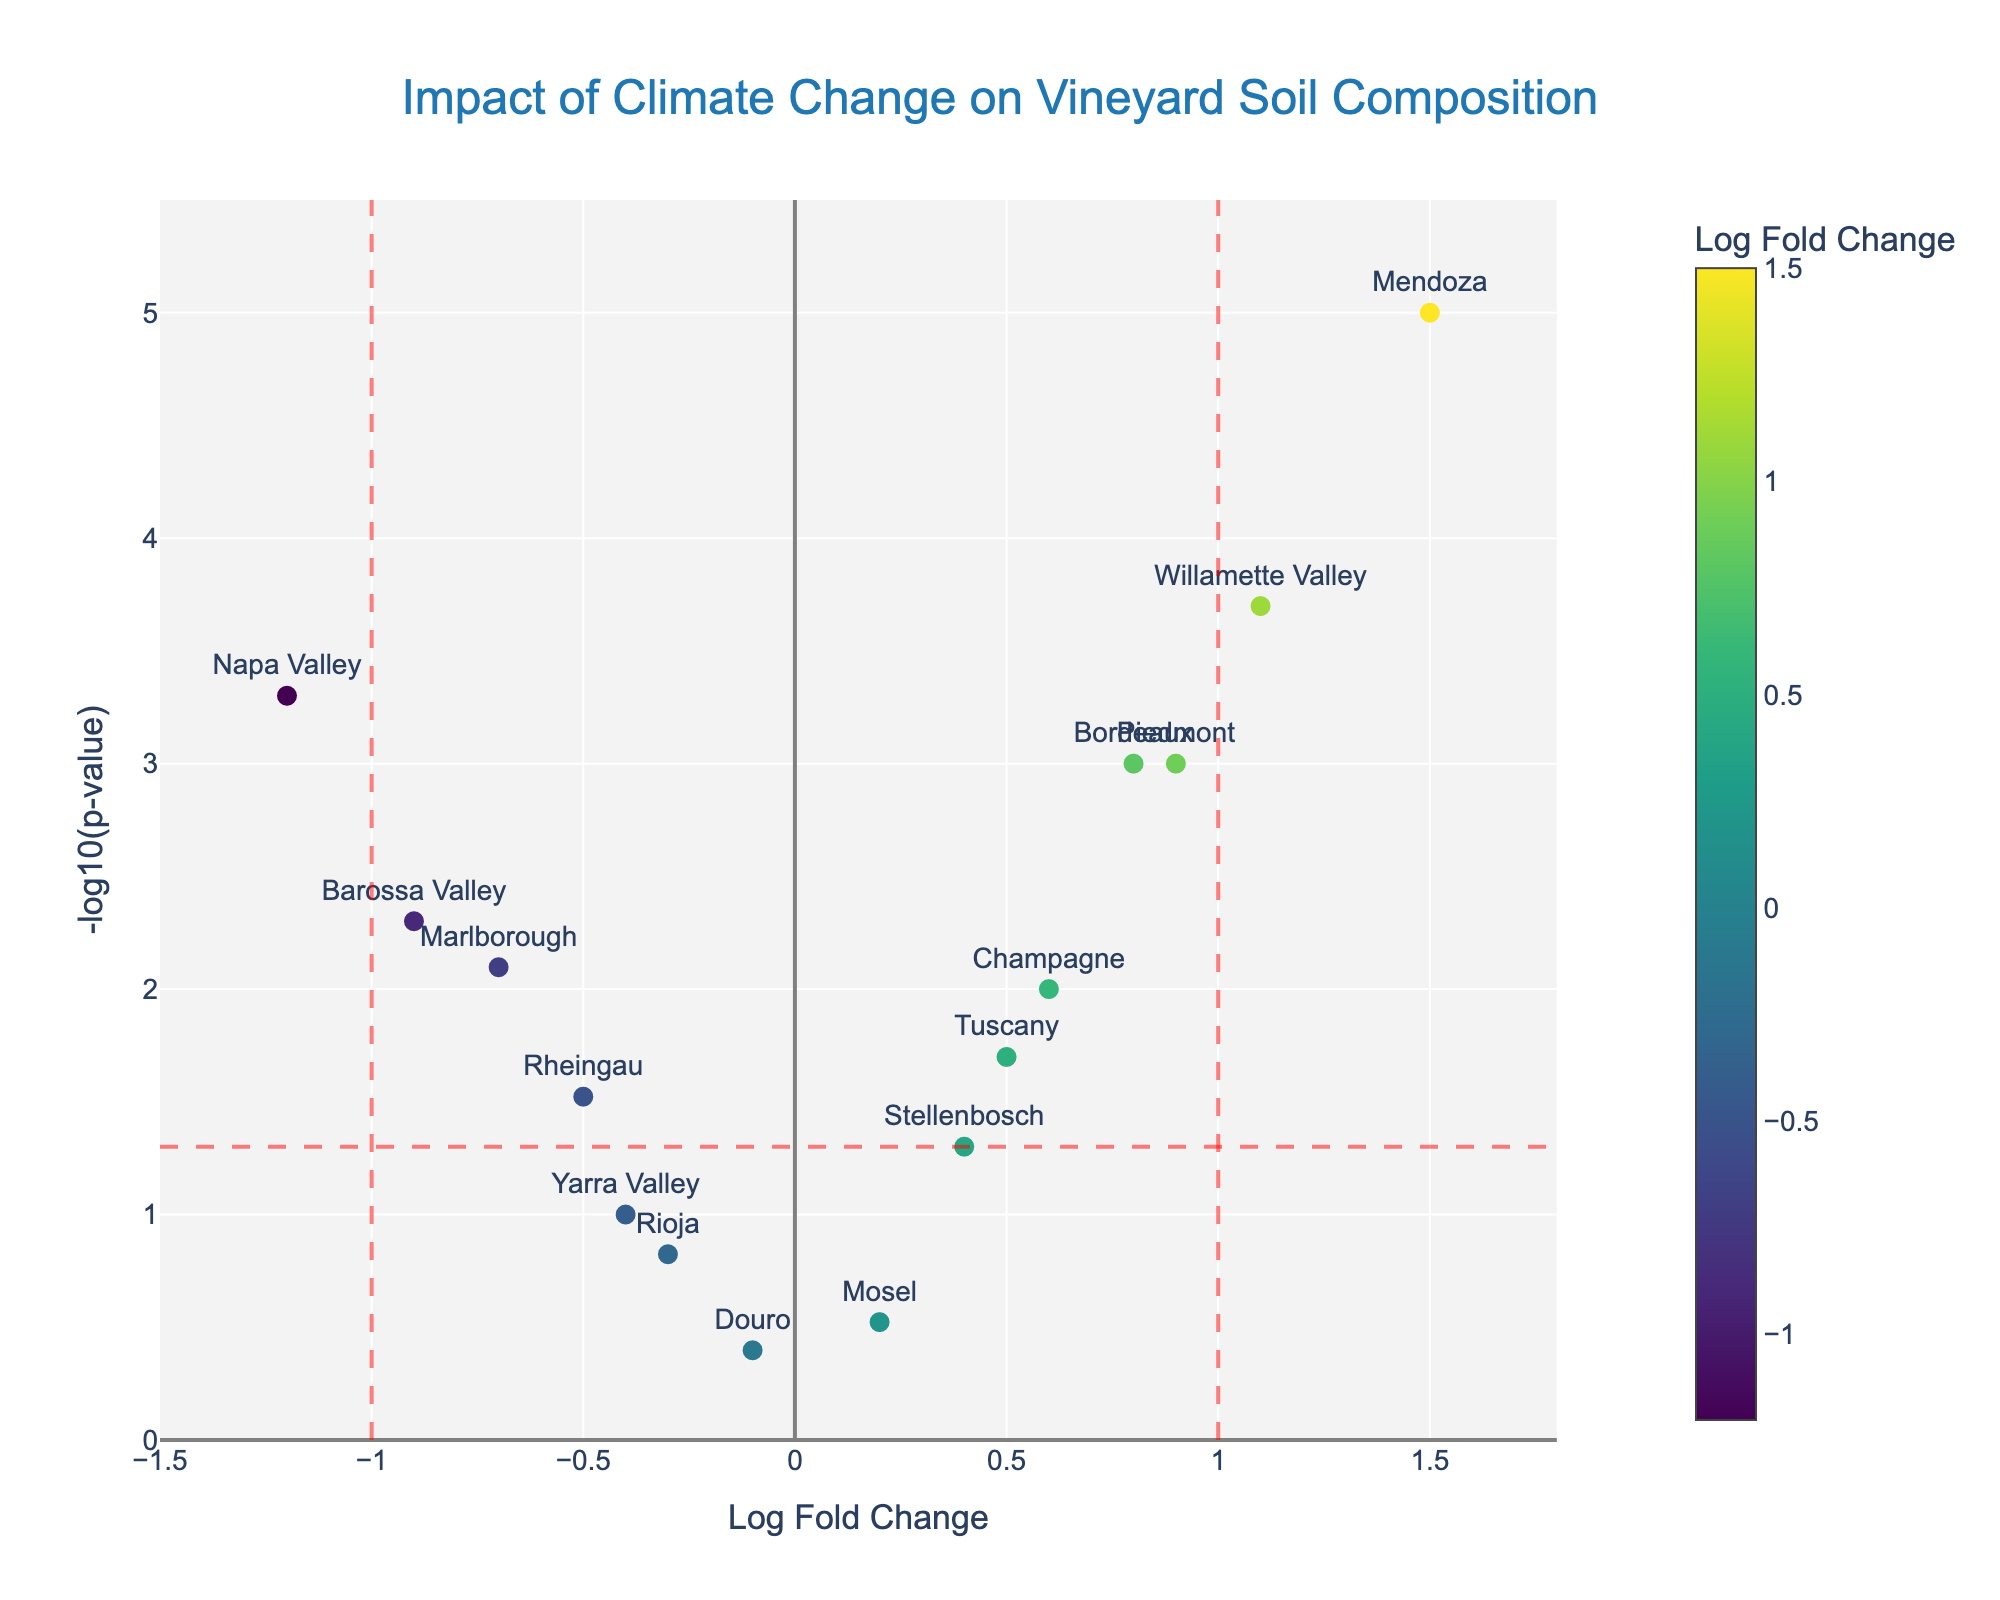Which region has the highest log fold change (LogFC)? The region with the highest log fold change is identified by finding the data point that has the maximum value on the x-axis.
Answer: Mendoza How many regions have a -log10(p-value) greater than 3? We need to count the number of data points above the horizontal line where -log10(p-value) is 3.
Answer: 5 Which regions have a LogFC between -1 and 1 and a p-value less than 0.05? These regions fall within the vertical dashed lines and are above the horizontal dashed line that represents -log10(0.05).
Answer: Bordeaux, Napa Valley, Tuscany, Champagne, Marlborough, Rheingau, Piedmont What does the color of each data point represent? The color of each data point represents the log fold change (LogFC) with a color scale provided.
Answer: Log Fold Change Which region shows the smallest impact of climate change in terms of log fold change? The region with the smallest log fold change is closest to zero on the x-axis.
Answer: Douro How many regions have statistically significant p-values (p < 0.05)? To find this, count the number of data points above the horizontal dashed line at -log10(0.05) = 1.3.
Answer: 10 Compare the log fold change (LogFC) of Bordeaux and Napa Valley. Which one has a higher change and by how much? Bordeaux has a LogFC of 0.8, and Napa Valley has a LogFC of -1.2. The difference is calculated by subtracting Napa Valley’s LogFC from Bordeaux's.
Answer: Bordeaux by 2.0 Which region has the highest statistical significance (lowest p-value)? The region with the highest statistical significance is identified by the highest value on the y-axis.
Answer: Mendoza Are there any regions that have a positive log fold change and are not statistically significant (p > 0.05)? These are regions with positive LogFC (right of zero on the x-axis) and below the horizontal line at -log10(0.05).
Answer: Mosel What are the extremes in the dataset regarding log fold change values, and which regions do they correspond to? Identify the maximum and minimum LogFC values and their corresponding regions.
Answer: Maximum: Mendoza (1.5), Minimum: Napa Valley (-1.2) 